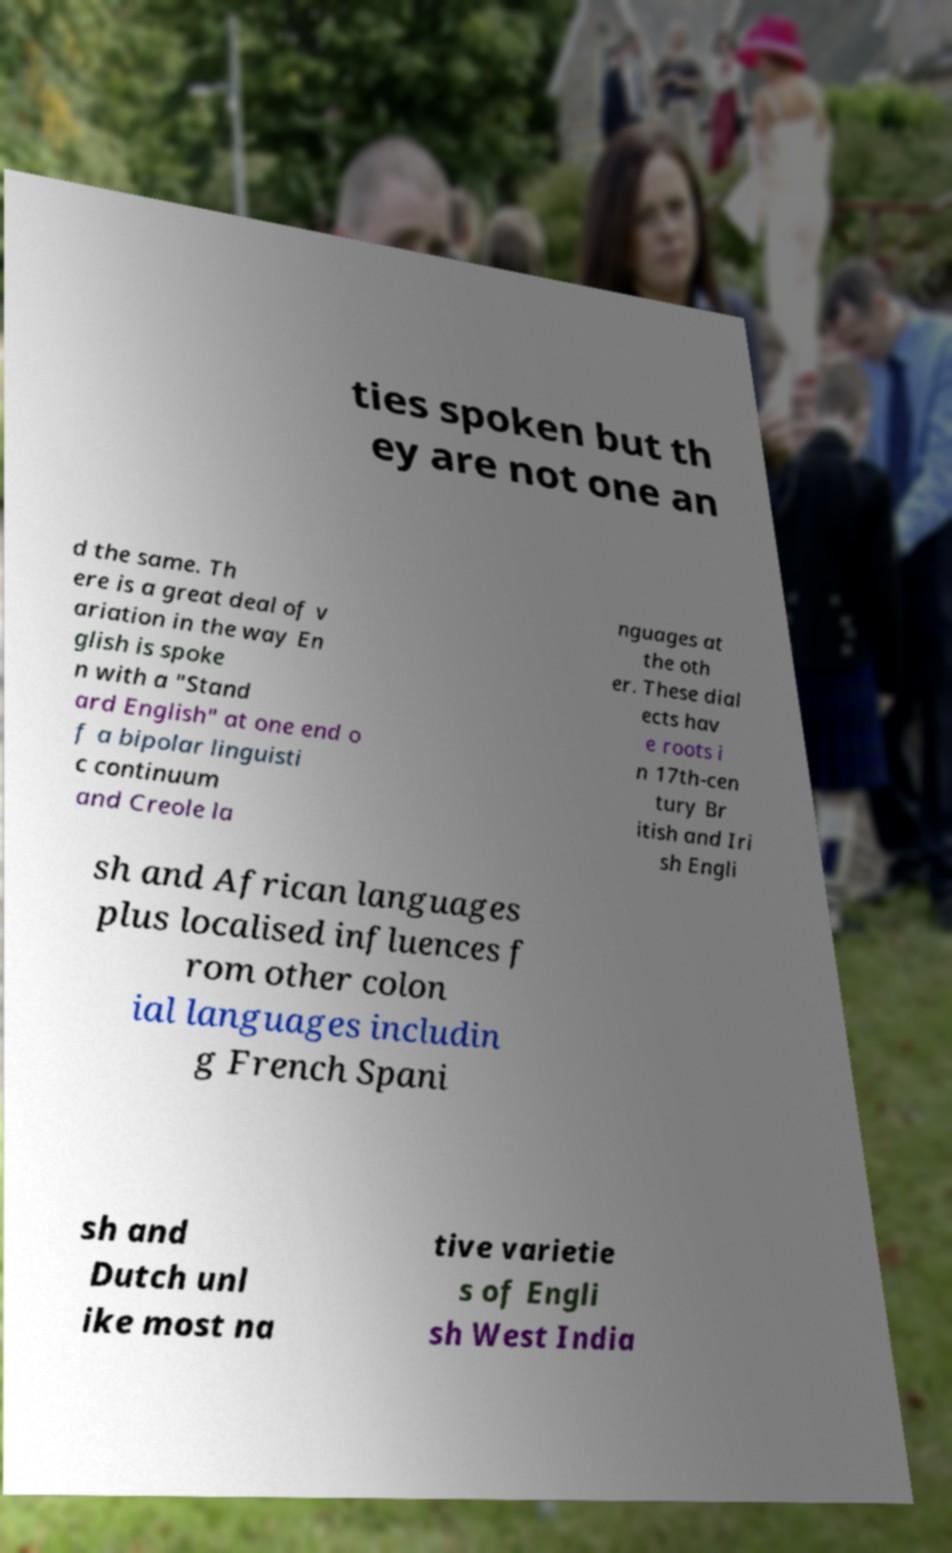I need the written content from this picture converted into text. Can you do that? ties spoken but th ey are not one an d the same. Th ere is a great deal of v ariation in the way En glish is spoke n with a "Stand ard English" at one end o f a bipolar linguisti c continuum and Creole la nguages at the oth er. These dial ects hav e roots i n 17th-cen tury Br itish and Iri sh Engli sh and African languages plus localised influences f rom other colon ial languages includin g French Spani sh and Dutch unl ike most na tive varietie s of Engli sh West India 